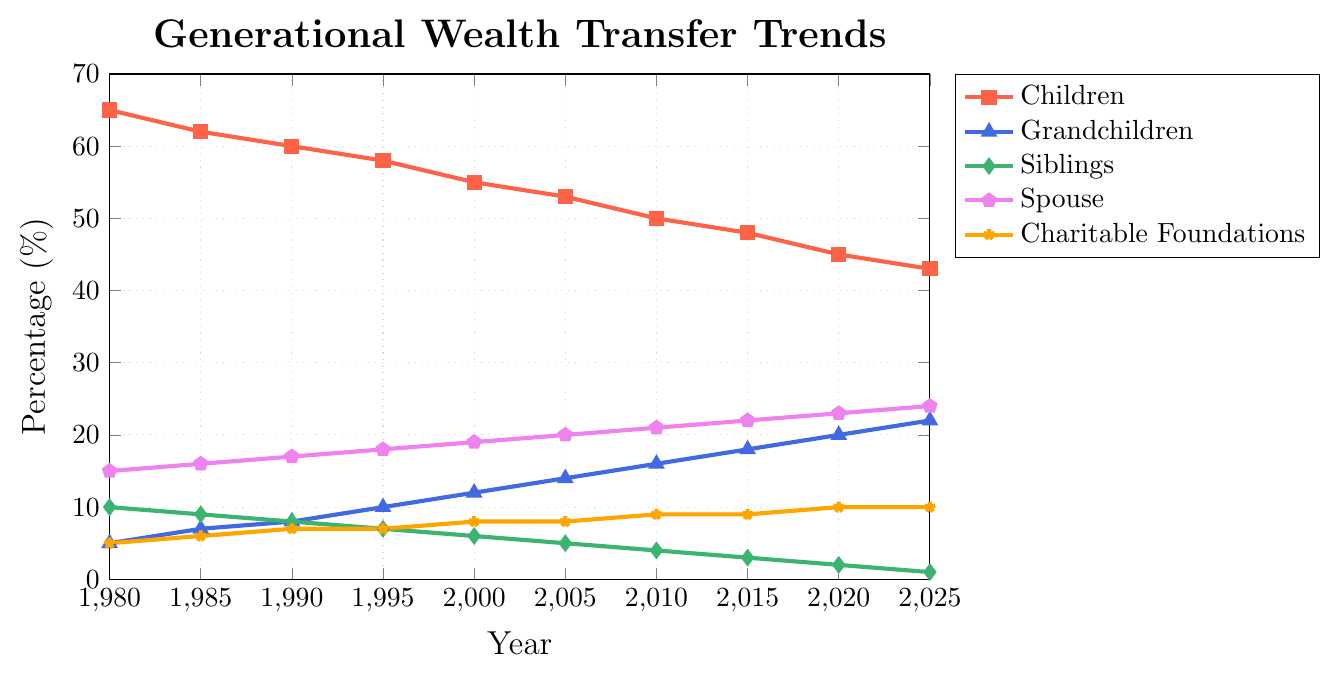What is the percentage of assets passed down to grandchildren in the year 2000? Look for the data point related to grandchildren for the year 2000, which is represented by a blue line in the graph.
Answer: 12 Which family member received an increasing percentage of assets over time? By examining the trends from 1980 to 2025, it is clear that the spouse's line is consistently rising.
Answer: Spouse What is the combined percentage of assets passed down to siblings and charitable foundations in 2015? Find the percentages for siblings and charitable foundations in 2015 and add them: 3% (siblings) + 9% (charitable foundations) = 12%.
Answer: 12% Between which years did the percentage of assets passed down to children drop by 10%? Look at the red line representing children and find the interval where it dropped from 60% to 50%. This happens between 1990 and 2000.
Answer: 1990 to 2000 How does the change in percentage of assets passed down to siblings compare to the change for charitable foundations between 1980 and 2025? For siblings, the percentage drops from 10% to 1%, a decrease of 9%. For charitable foundations, the percentage increases from 5% to 10%, an increase of 5%.
Answer: Siblings: -9%, Charitable: +5% What is the average percentage of assets passed down to grandchild between 1980 and 2025? Sum all values for grandchildren from 1980 to 2025 and divide by the number of data points: (5+7+8+10+12+14+16+18+20+22)/10 = 13.2%.
Answer: 13.2% In what year did the percentage of assets passed down to the spouse reach 20%? Look for the year when the purple line representing the spouse crosses the 20% mark.
Answer: 2005 Which category shows the steepest decline over the years portrayed in the chart? The green line representing siblings shows the steepest decline from 10% in 1980 to 1% in 2025, dropping steadily over the years.
Answer: Siblings What is the difference in the percentage of assets passed down to grandchildren between 2005 and 2020? Identify the values for grandchildren in 2005 (14%) and 2020 (20%), then calculate the difference (20% -14% = 6%).
Answer: 6% 